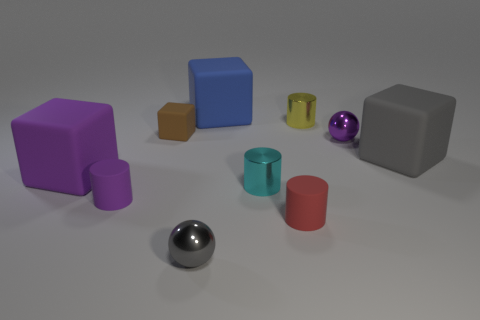There is a small metal thing that is to the left of the blue rubber object; is its shape the same as the cyan object?
Offer a very short reply. No. What material is the tiny purple thing that is in front of the cyan metallic object?
Your answer should be very brief. Rubber. Are there any small brown cubes made of the same material as the gray cube?
Provide a succinct answer. Yes. How big is the cyan object?
Your answer should be very brief. Small. How many yellow objects are either large rubber blocks or rubber things?
Your response must be concise. 0. What number of other rubber objects are the same shape as the small red thing?
Make the answer very short. 1. What number of red shiny spheres are the same size as the red matte thing?
Provide a succinct answer. 0. There is a tiny cyan thing that is the same shape as the tiny purple matte object; what is it made of?
Provide a succinct answer. Metal. What is the color of the large rubber thing that is behind the tiny brown cube?
Give a very brief answer. Blue. Is the number of objects that are in front of the small red cylinder greater than the number of big blue cylinders?
Provide a succinct answer. Yes. 